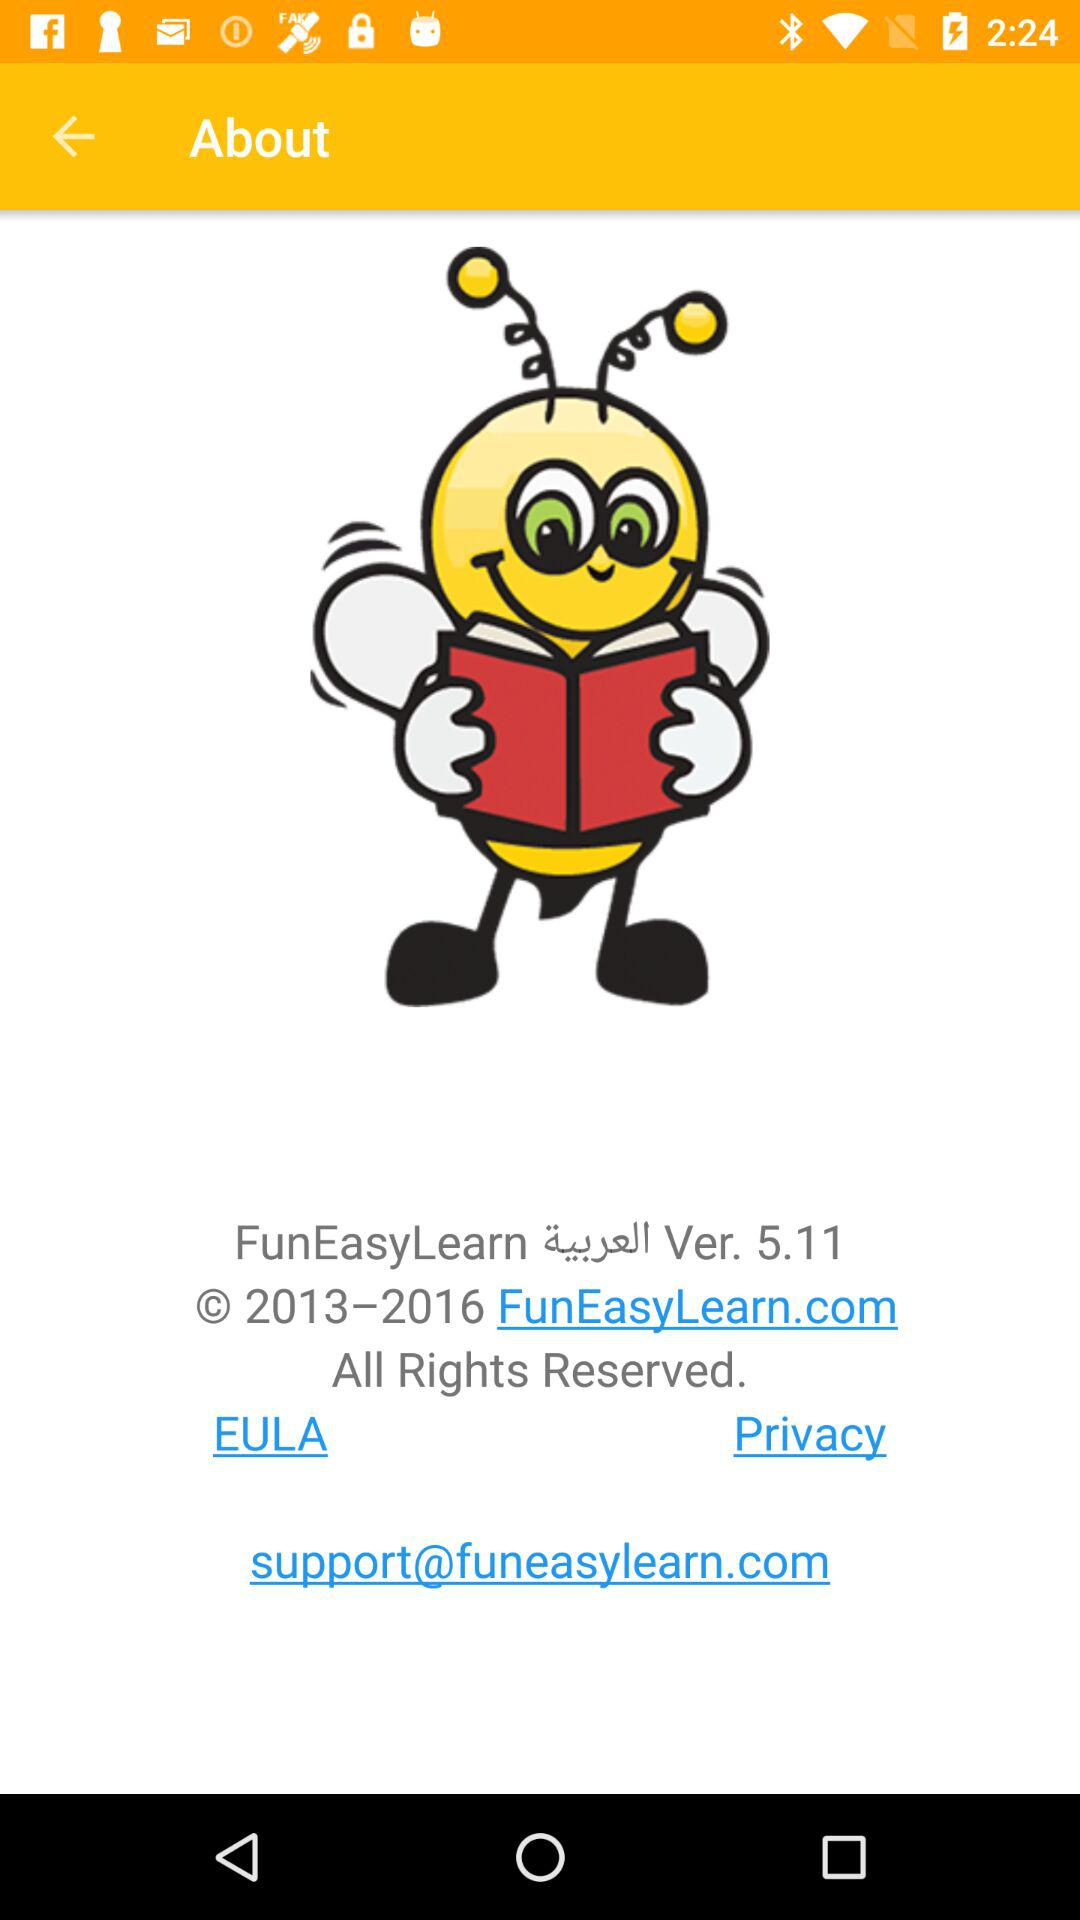What is the version? The version is 5.11. 